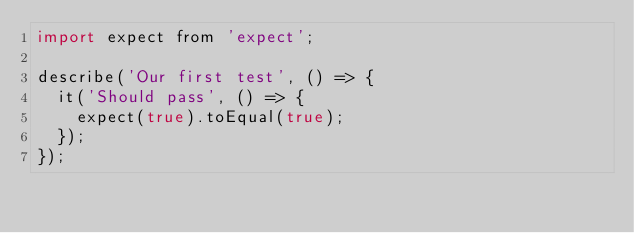Convert code to text. <code><loc_0><loc_0><loc_500><loc_500><_JavaScript_>import expect from 'expect';

describe('Our first test', () => {
  it('Should pass', () => {
    expect(true).toEqual(true);
  });
});
</code> 